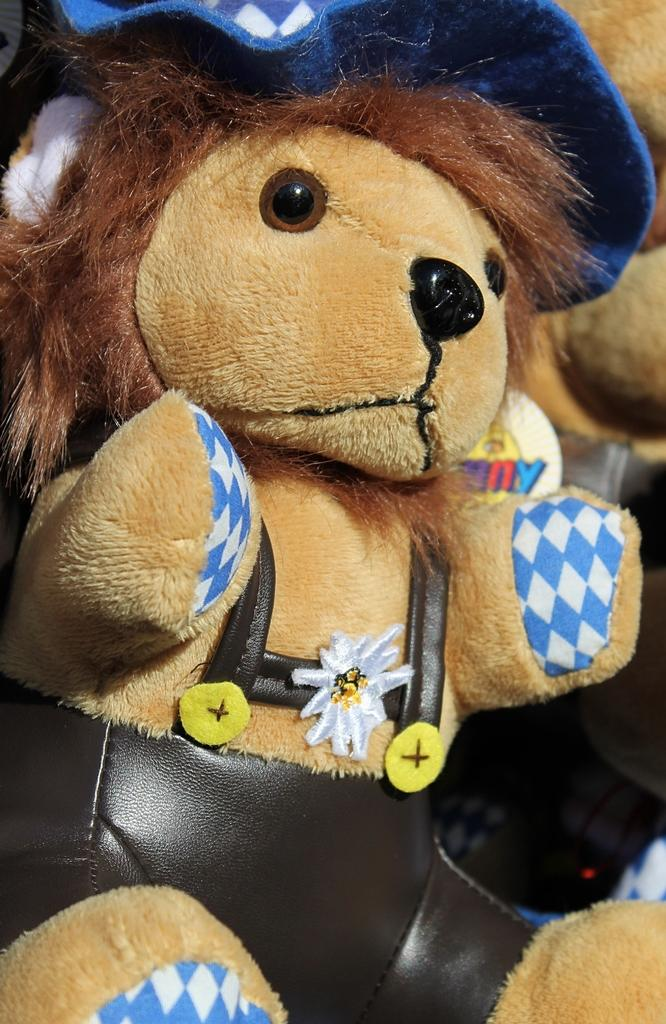What is in the foreground of the image? There is a soft toy in the foreground of the image. What is the soft toy wearing? The soft toy is wearing a black dress and a blue hat. Are there any other soft toys visible in the image? Yes, there are other soft toys in the background of the image. How does the soft toy contribute to society in the image? The image does not depict the soft toy's contribution to society, as it is a still image of a toy. Can you explain how the soft toy is pulling the other soft toys in the image? There is no indication in the image that the soft toy is pulling or interacting with the other soft toys; they are simply present in the background. 